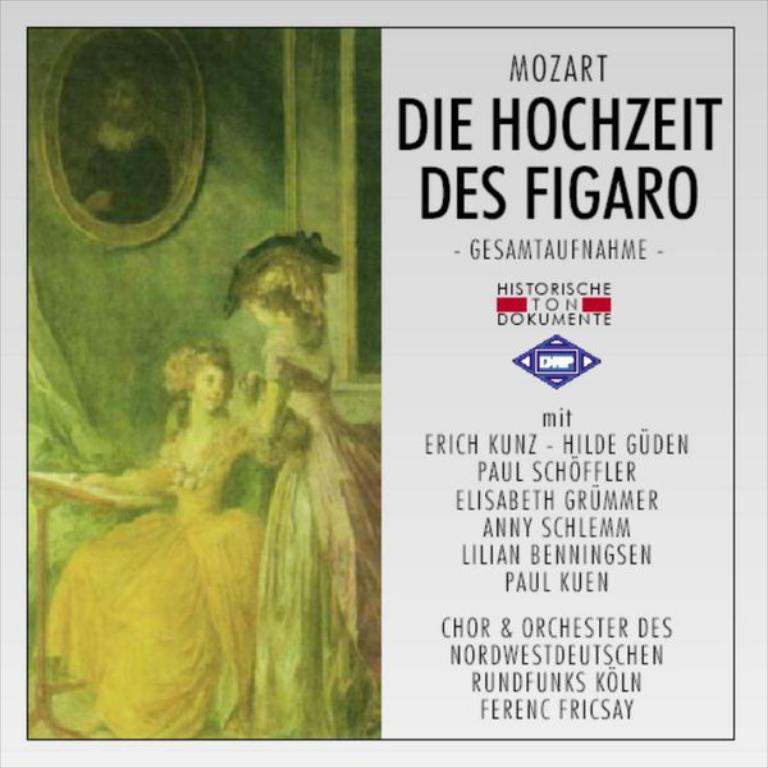<image>
Present a compact description of the photo's key features. An album featuring Mozart contains choir and orchestra performers 